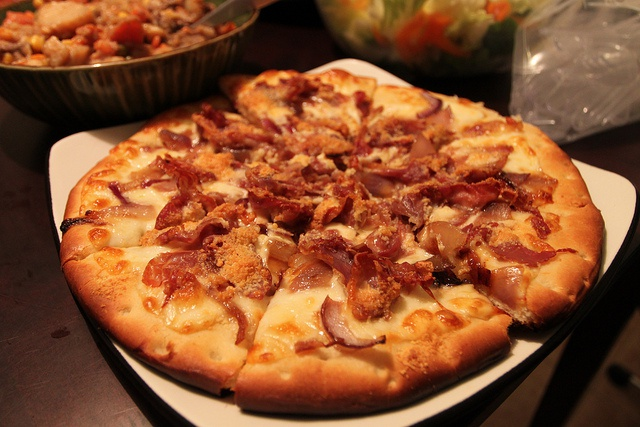Describe the objects in this image and their specific colors. I can see pizza in brown, orange, and red tones, dining table in brown, black, and maroon tones, bowl in brown, black, and maroon tones, and fork in brown, gray, and tan tones in this image. 